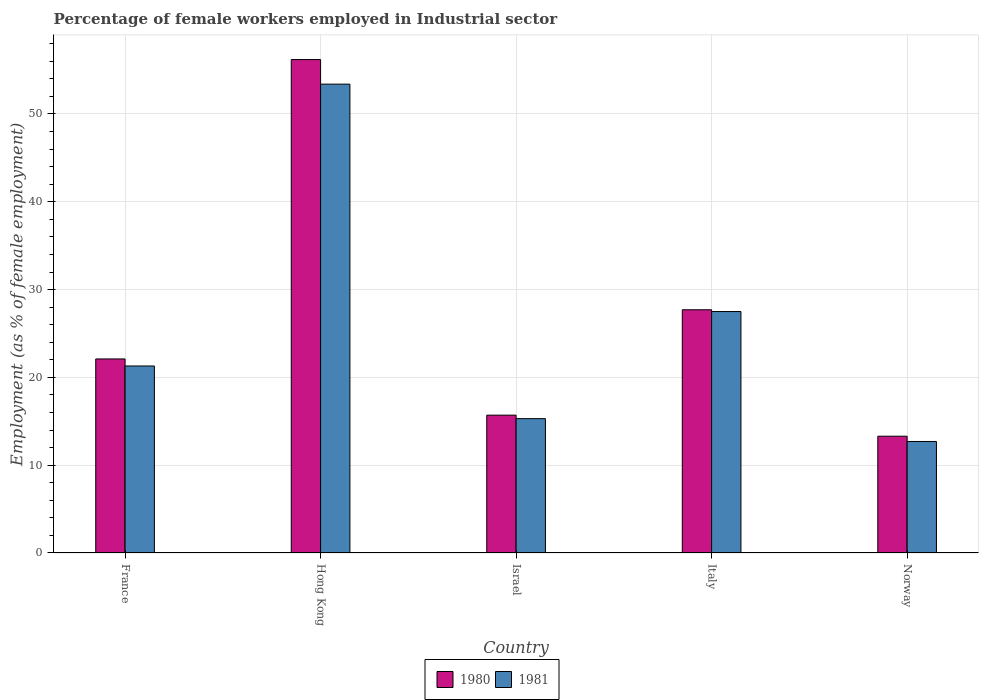How many different coloured bars are there?
Provide a short and direct response. 2. How many groups of bars are there?
Offer a very short reply. 5. Are the number of bars per tick equal to the number of legend labels?
Make the answer very short. Yes. Are the number of bars on each tick of the X-axis equal?
Give a very brief answer. Yes. How many bars are there on the 2nd tick from the right?
Make the answer very short. 2. What is the label of the 3rd group of bars from the left?
Keep it short and to the point. Israel. In how many cases, is the number of bars for a given country not equal to the number of legend labels?
Provide a succinct answer. 0. What is the percentage of females employed in Industrial sector in 1980 in Italy?
Your answer should be compact. 27.7. Across all countries, what is the maximum percentage of females employed in Industrial sector in 1981?
Give a very brief answer. 53.4. Across all countries, what is the minimum percentage of females employed in Industrial sector in 1981?
Make the answer very short. 12.7. In which country was the percentage of females employed in Industrial sector in 1980 maximum?
Your answer should be very brief. Hong Kong. What is the total percentage of females employed in Industrial sector in 1980 in the graph?
Offer a terse response. 135. What is the difference between the percentage of females employed in Industrial sector in 1981 in Hong Kong and that in Italy?
Keep it short and to the point. 25.9. What is the difference between the percentage of females employed in Industrial sector in 1981 in Hong Kong and the percentage of females employed in Industrial sector in 1980 in Israel?
Your answer should be very brief. 37.7. What is the average percentage of females employed in Industrial sector in 1981 per country?
Your answer should be compact. 26.04. What is the difference between the percentage of females employed in Industrial sector of/in 1981 and percentage of females employed in Industrial sector of/in 1980 in Israel?
Offer a very short reply. -0.4. What is the ratio of the percentage of females employed in Industrial sector in 1981 in France to that in Israel?
Ensure brevity in your answer.  1.39. What is the difference between the highest and the second highest percentage of females employed in Industrial sector in 1980?
Provide a short and direct response. 28.5. What is the difference between the highest and the lowest percentage of females employed in Industrial sector in 1980?
Your answer should be very brief. 42.9. Is the sum of the percentage of females employed in Industrial sector in 1981 in France and Israel greater than the maximum percentage of females employed in Industrial sector in 1980 across all countries?
Your answer should be compact. No. How many countries are there in the graph?
Offer a terse response. 5. Are the values on the major ticks of Y-axis written in scientific E-notation?
Offer a very short reply. No. Does the graph contain grids?
Provide a succinct answer. Yes. How many legend labels are there?
Keep it short and to the point. 2. How are the legend labels stacked?
Ensure brevity in your answer.  Horizontal. What is the title of the graph?
Give a very brief answer. Percentage of female workers employed in Industrial sector. Does "1970" appear as one of the legend labels in the graph?
Ensure brevity in your answer.  No. What is the label or title of the X-axis?
Your response must be concise. Country. What is the label or title of the Y-axis?
Offer a terse response. Employment (as % of female employment). What is the Employment (as % of female employment) of 1980 in France?
Provide a succinct answer. 22.1. What is the Employment (as % of female employment) in 1981 in France?
Your answer should be compact. 21.3. What is the Employment (as % of female employment) of 1980 in Hong Kong?
Your response must be concise. 56.2. What is the Employment (as % of female employment) in 1981 in Hong Kong?
Your response must be concise. 53.4. What is the Employment (as % of female employment) in 1980 in Israel?
Your answer should be very brief. 15.7. What is the Employment (as % of female employment) in 1981 in Israel?
Your answer should be very brief. 15.3. What is the Employment (as % of female employment) in 1980 in Italy?
Your response must be concise. 27.7. What is the Employment (as % of female employment) in 1980 in Norway?
Keep it short and to the point. 13.3. What is the Employment (as % of female employment) of 1981 in Norway?
Give a very brief answer. 12.7. Across all countries, what is the maximum Employment (as % of female employment) of 1980?
Ensure brevity in your answer.  56.2. Across all countries, what is the maximum Employment (as % of female employment) of 1981?
Offer a very short reply. 53.4. Across all countries, what is the minimum Employment (as % of female employment) of 1980?
Provide a succinct answer. 13.3. Across all countries, what is the minimum Employment (as % of female employment) of 1981?
Keep it short and to the point. 12.7. What is the total Employment (as % of female employment) of 1980 in the graph?
Your response must be concise. 135. What is the total Employment (as % of female employment) in 1981 in the graph?
Offer a terse response. 130.2. What is the difference between the Employment (as % of female employment) in 1980 in France and that in Hong Kong?
Offer a terse response. -34.1. What is the difference between the Employment (as % of female employment) in 1981 in France and that in Hong Kong?
Provide a succinct answer. -32.1. What is the difference between the Employment (as % of female employment) in 1981 in France and that in Israel?
Ensure brevity in your answer.  6. What is the difference between the Employment (as % of female employment) of 1981 in France and that in Italy?
Offer a very short reply. -6.2. What is the difference between the Employment (as % of female employment) in 1980 in France and that in Norway?
Provide a short and direct response. 8.8. What is the difference between the Employment (as % of female employment) in 1980 in Hong Kong and that in Israel?
Make the answer very short. 40.5. What is the difference between the Employment (as % of female employment) in 1981 in Hong Kong and that in Israel?
Your answer should be compact. 38.1. What is the difference between the Employment (as % of female employment) in 1980 in Hong Kong and that in Italy?
Provide a succinct answer. 28.5. What is the difference between the Employment (as % of female employment) of 1981 in Hong Kong and that in Italy?
Your answer should be very brief. 25.9. What is the difference between the Employment (as % of female employment) of 1980 in Hong Kong and that in Norway?
Make the answer very short. 42.9. What is the difference between the Employment (as % of female employment) of 1981 in Hong Kong and that in Norway?
Your answer should be very brief. 40.7. What is the difference between the Employment (as % of female employment) in 1980 in Israel and that in Italy?
Provide a succinct answer. -12. What is the difference between the Employment (as % of female employment) in 1981 in Israel and that in Italy?
Provide a succinct answer. -12.2. What is the difference between the Employment (as % of female employment) in 1980 in Israel and that in Norway?
Offer a terse response. 2.4. What is the difference between the Employment (as % of female employment) in 1980 in Italy and that in Norway?
Provide a short and direct response. 14.4. What is the difference between the Employment (as % of female employment) in 1981 in Italy and that in Norway?
Offer a very short reply. 14.8. What is the difference between the Employment (as % of female employment) in 1980 in France and the Employment (as % of female employment) in 1981 in Hong Kong?
Your response must be concise. -31.3. What is the difference between the Employment (as % of female employment) of 1980 in France and the Employment (as % of female employment) of 1981 in Israel?
Your response must be concise. 6.8. What is the difference between the Employment (as % of female employment) of 1980 in France and the Employment (as % of female employment) of 1981 in Italy?
Offer a very short reply. -5.4. What is the difference between the Employment (as % of female employment) in 1980 in Hong Kong and the Employment (as % of female employment) in 1981 in Israel?
Provide a short and direct response. 40.9. What is the difference between the Employment (as % of female employment) in 1980 in Hong Kong and the Employment (as % of female employment) in 1981 in Italy?
Make the answer very short. 28.7. What is the difference between the Employment (as % of female employment) of 1980 in Hong Kong and the Employment (as % of female employment) of 1981 in Norway?
Give a very brief answer. 43.5. What is the difference between the Employment (as % of female employment) of 1980 in Israel and the Employment (as % of female employment) of 1981 in Norway?
Your response must be concise. 3. What is the difference between the Employment (as % of female employment) of 1980 in Italy and the Employment (as % of female employment) of 1981 in Norway?
Your answer should be very brief. 15. What is the average Employment (as % of female employment) in 1980 per country?
Your answer should be compact. 27. What is the average Employment (as % of female employment) of 1981 per country?
Your answer should be compact. 26.04. What is the difference between the Employment (as % of female employment) in 1980 and Employment (as % of female employment) in 1981 in Israel?
Offer a terse response. 0.4. What is the difference between the Employment (as % of female employment) in 1980 and Employment (as % of female employment) in 1981 in Italy?
Keep it short and to the point. 0.2. What is the ratio of the Employment (as % of female employment) of 1980 in France to that in Hong Kong?
Provide a short and direct response. 0.39. What is the ratio of the Employment (as % of female employment) of 1981 in France to that in Hong Kong?
Offer a terse response. 0.4. What is the ratio of the Employment (as % of female employment) of 1980 in France to that in Israel?
Provide a succinct answer. 1.41. What is the ratio of the Employment (as % of female employment) of 1981 in France to that in Israel?
Make the answer very short. 1.39. What is the ratio of the Employment (as % of female employment) of 1980 in France to that in Italy?
Offer a very short reply. 0.8. What is the ratio of the Employment (as % of female employment) in 1981 in France to that in Italy?
Your response must be concise. 0.77. What is the ratio of the Employment (as % of female employment) in 1980 in France to that in Norway?
Ensure brevity in your answer.  1.66. What is the ratio of the Employment (as % of female employment) in 1981 in France to that in Norway?
Offer a terse response. 1.68. What is the ratio of the Employment (as % of female employment) of 1980 in Hong Kong to that in Israel?
Ensure brevity in your answer.  3.58. What is the ratio of the Employment (as % of female employment) of 1981 in Hong Kong to that in Israel?
Offer a terse response. 3.49. What is the ratio of the Employment (as % of female employment) of 1980 in Hong Kong to that in Italy?
Keep it short and to the point. 2.03. What is the ratio of the Employment (as % of female employment) of 1981 in Hong Kong to that in Italy?
Provide a succinct answer. 1.94. What is the ratio of the Employment (as % of female employment) of 1980 in Hong Kong to that in Norway?
Make the answer very short. 4.23. What is the ratio of the Employment (as % of female employment) in 1981 in Hong Kong to that in Norway?
Give a very brief answer. 4.2. What is the ratio of the Employment (as % of female employment) of 1980 in Israel to that in Italy?
Your answer should be compact. 0.57. What is the ratio of the Employment (as % of female employment) in 1981 in Israel to that in Italy?
Keep it short and to the point. 0.56. What is the ratio of the Employment (as % of female employment) of 1980 in Israel to that in Norway?
Provide a succinct answer. 1.18. What is the ratio of the Employment (as % of female employment) of 1981 in Israel to that in Norway?
Give a very brief answer. 1.2. What is the ratio of the Employment (as % of female employment) of 1980 in Italy to that in Norway?
Provide a succinct answer. 2.08. What is the ratio of the Employment (as % of female employment) of 1981 in Italy to that in Norway?
Keep it short and to the point. 2.17. What is the difference between the highest and the second highest Employment (as % of female employment) in 1980?
Your answer should be very brief. 28.5. What is the difference between the highest and the second highest Employment (as % of female employment) of 1981?
Your answer should be compact. 25.9. What is the difference between the highest and the lowest Employment (as % of female employment) of 1980?
Give a very brief answer. 42.9. What is the difference between the highest and the lowest Employment (as % of female employment) in 1981?
Your answer should be very brief. 40.7. 